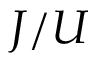Convert formula to latex. <formula><loc_0><loc_0><loc_500><loc_500>J / U</formula> 